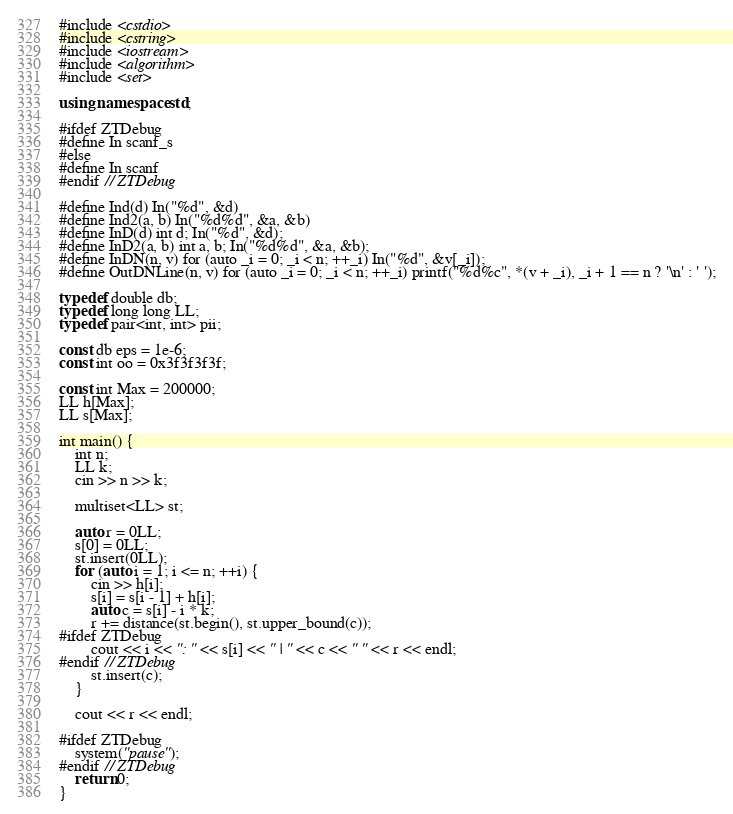<code> <loc_0><loc_0><loc_500><loc_500><_C++_>#include <cstdio>
#include <cstring>
#include <iostream>
#include <algorithm>
#include <set>

using namespace std;

#ifdef ZTDebug
#define In scanf_s
#else
#define In scanf
#endif // ZTDebug

#define Ind(d) In("%d", &d)
#define Ind2(a, b) In("%d%d", &a, &b)
#define InD(d) int d; In("%d", &d);
#define InD2(a, b) int a, b; In("%d%d", &a, &b);
#define InDN(n, v) for (auto _i = 0; _i < n; ++_i) In("%d", &v[_i]);
#define OutDNLine(n, v) for (auto _i = 0; _i < n; ++_i) printf("%d%c", *(v + _i), _i + 1 == n ? '\n' : ' ');

typedef double db;
typedef long long LL;
typedef pair<int, int> pii;

const db eps = 1e-6;
const int oo = 0x3f3f3f3f;

const int Max = 200000;
LL h[Max];
LL s[Max];

int main() {
    int n;
    LL k;
    cin >> n >> k;

    multiset<LL> st;

    auto r = 0LL;
    s[0] = 0LL;
    st.insert(0LL);
    for (auto i = 1; i <= n; ++i) {
        cin >> h[i];
        s[i] = s[i - 1] + h[i];
        auto c = s[i] - i * k;
        r += distance(st.begin(), st.upper_bound(c));
#ifdef ZTDebug
        cout << i << ": " << s[i] << " | " << c << " " << r << endl;
#endif // ZTDebug
        st.insert(c);
    }

    cout << r << endl;

#ifdef ZTDebug
    system("pause");
#endif // ZTDebug
    return 0;
}
</code> 